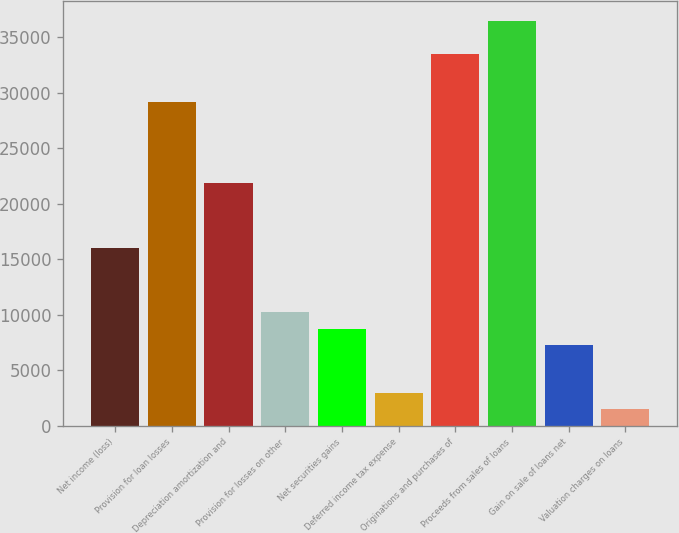<chart> <loc_0><loc_0><loc_500><loc_500><bar_chart><fcel>Net income (loss)<fcel>Provision for loan losses<fcel>Depreciation amortization and<fcel>Provision for losses on other<fcel>Net securities gains<fcel>Deferred income tax expense<fcel>Originations and purchases of<fcel>Proceeds from sales of loans<fcel>Gain on sale of loans net<fcel>Valuation charges on loans<nl><fcel>16050.3<fcel>29175<fcel>21883.5<fcel>10217.1<fcel>8758.8<fcel>2925.6<fcel>33549.9<fcel>36466.5<fcel>7300.5<fcel>1467.3<nl></chart> 